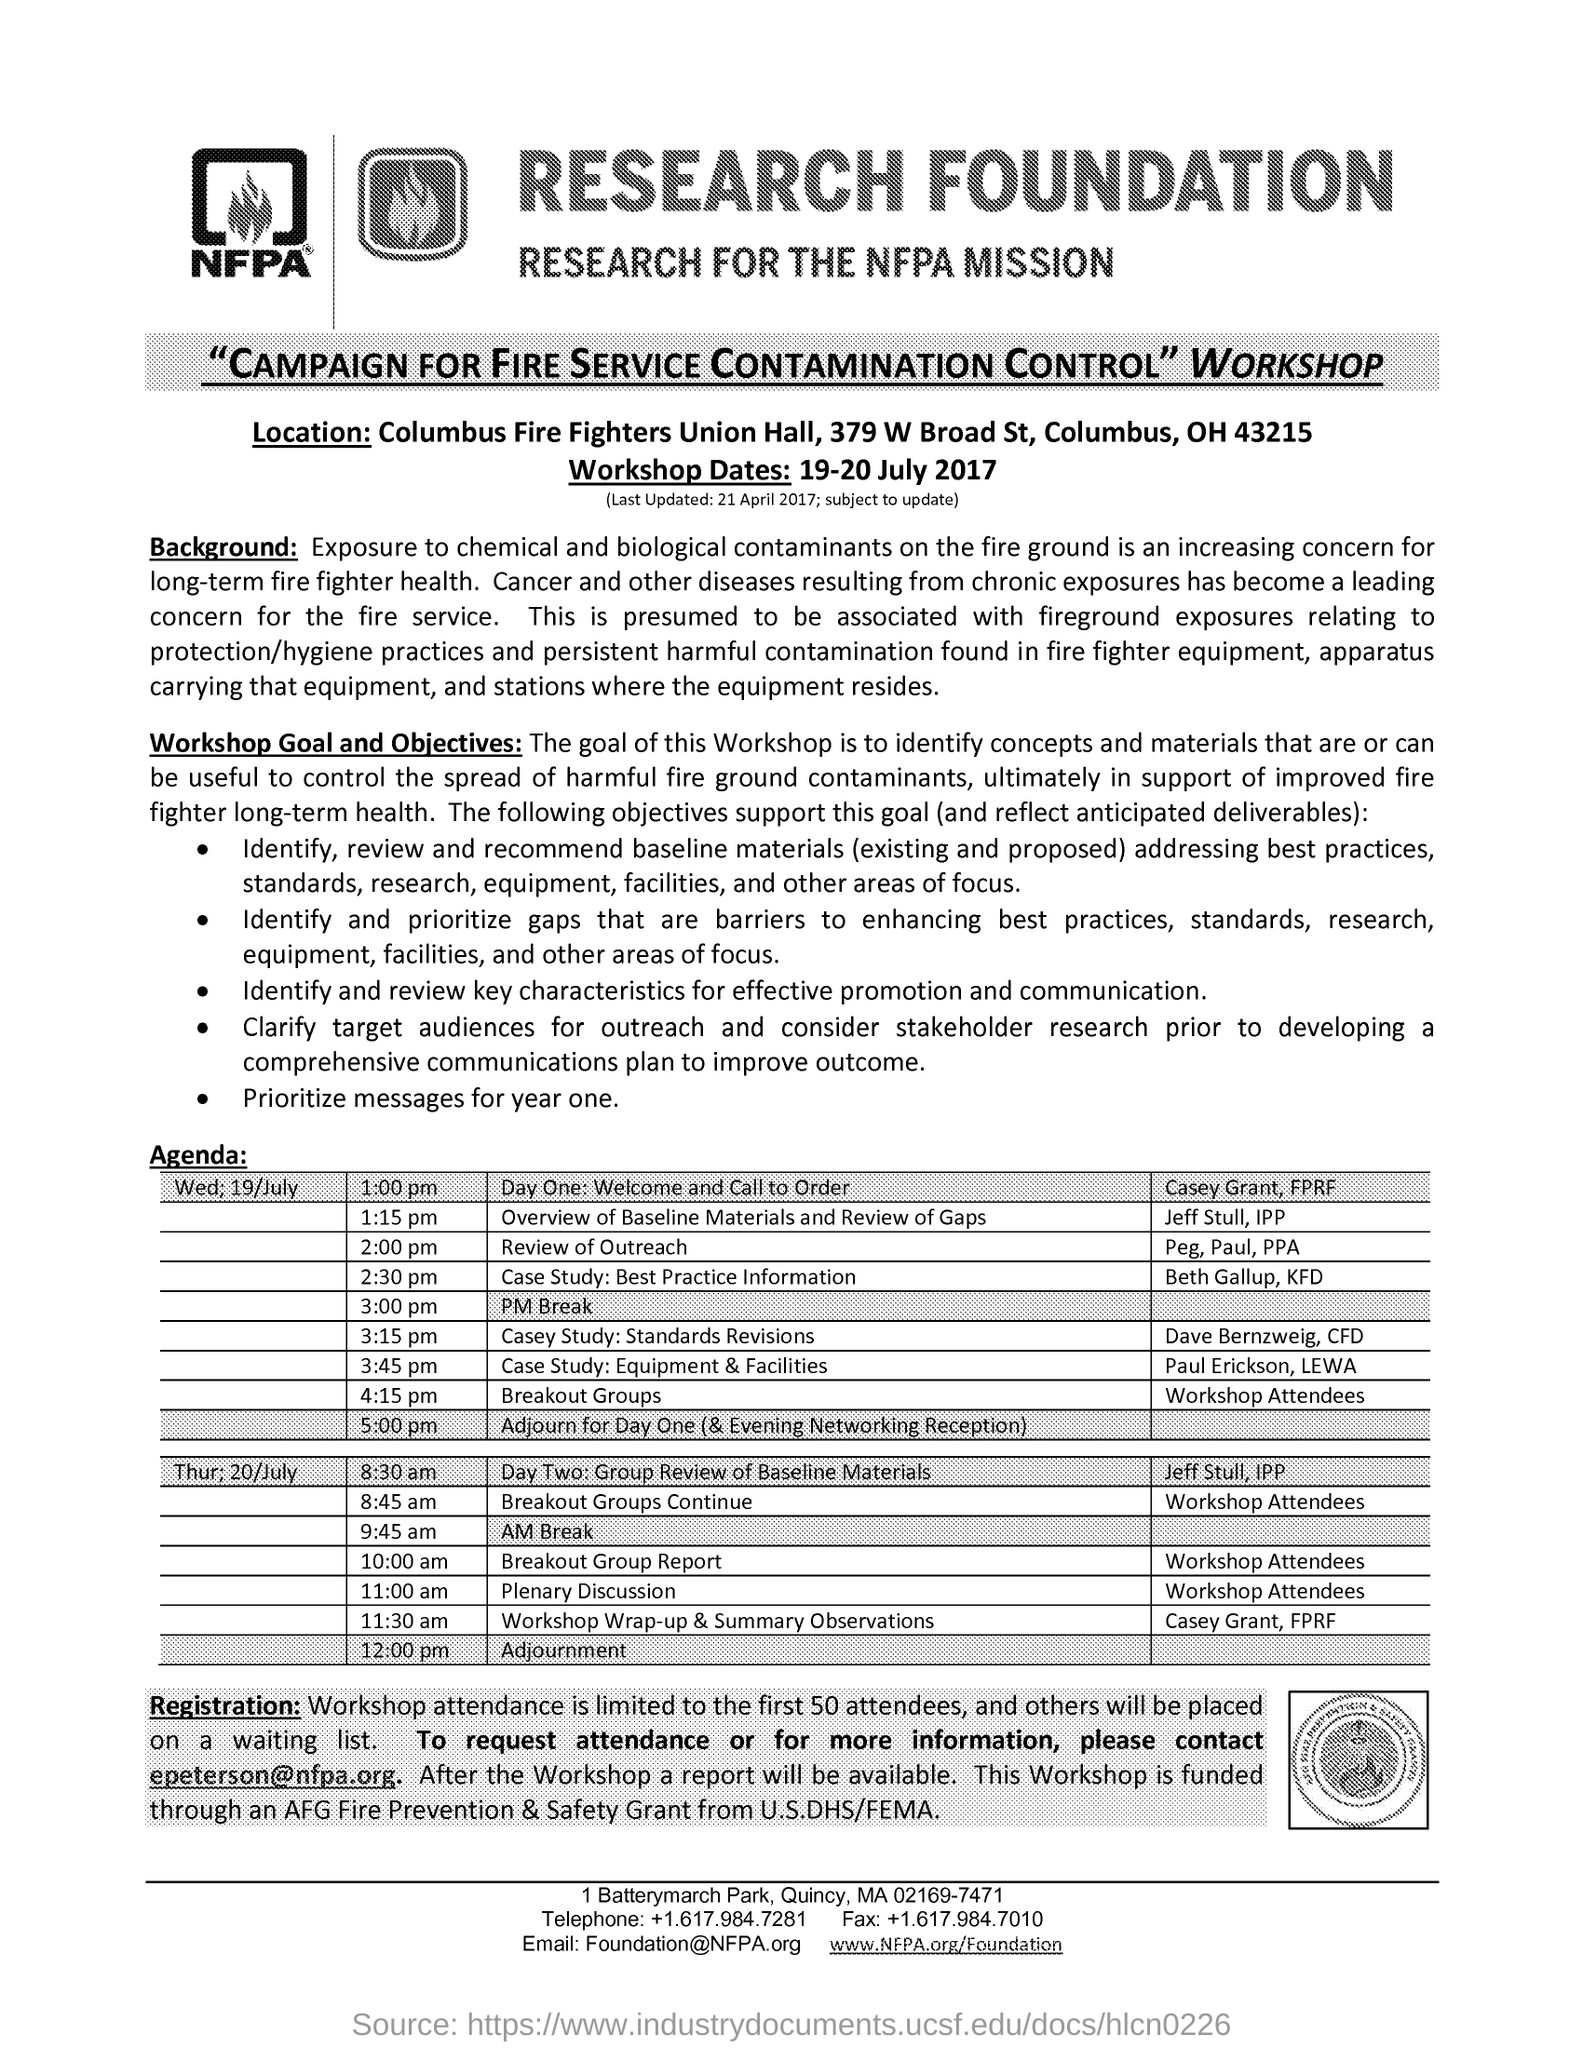What is the Goal of this Workshop?
Offer a very short reply. Is to identify concepts and materials that are or can be useful to control the spread of harmful fire ground contaminants, ultimately in support of improved fire fighter long-term health. What is the limit of Workshop attendance?
Keep it short and to the point. Is limited to the first 50 attendees,. When is the Workshop?
Your response must be concise. 19-20 July 2017. 